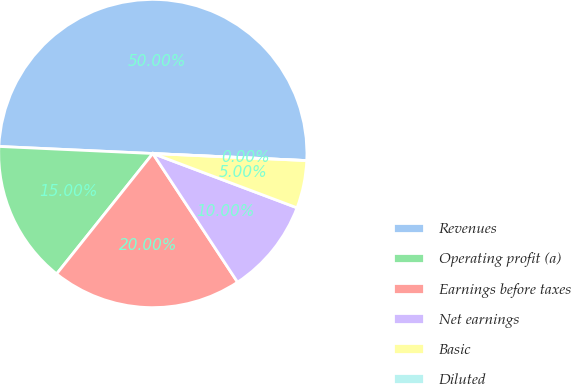Convert chart. <chart><loc_0><loc_0><loc_500><loc_500><pie_chart><fcel>Revenues<fcel>Operating profit (a)<fcel>Earnings before taxes<fcel>Net earnings<fcel>Basic<fcel>Diluted<nl><fcel>50.0%<fcel>15.0%<fcel>20.0%<fcel>10.0%<fcel>5.0%<fcel>0.0%<nl></chart> 